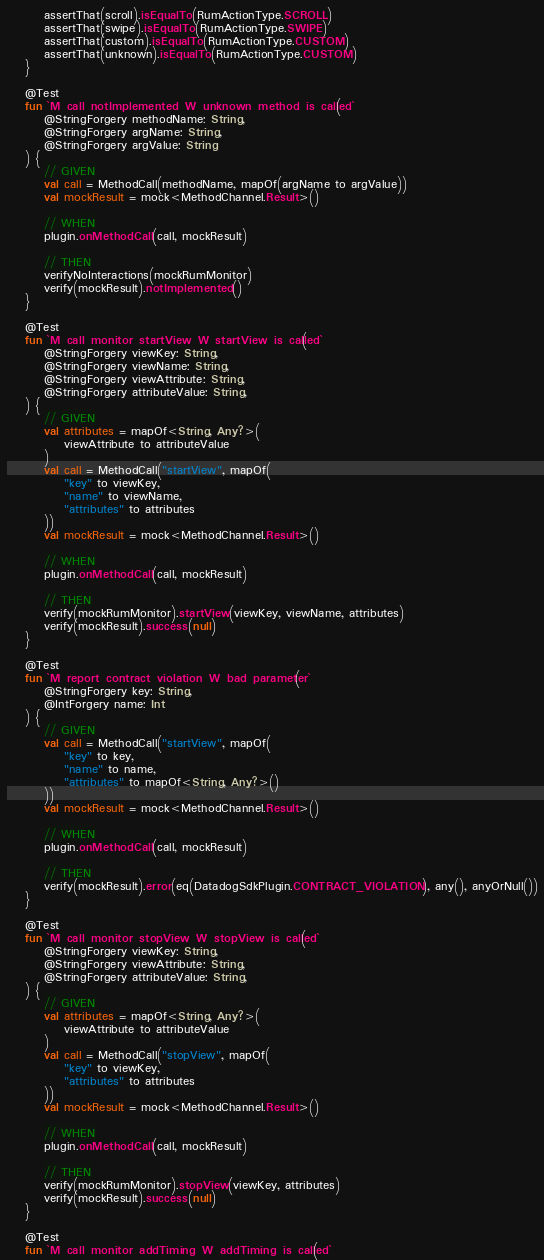<code> <loc_0><loc_0><loc_500><loc_500><_Kotlin_>        assertThat(scroll).isEqualTo(RumActionType.SCROLL)
        assertThat(swipe).isEqualTo(RumActionType.SWIPE)
        assertThat(custom).isEqualTo(RumActionType.CUSTOM)
        assertThat(unknown).isEqualTo(RumActionType.CUSTOM)
    }

    @Test
    fun `M call notImplemented W unknown method is called`(
        @StringForgery methodName: String,
        @StringForgery argName: String,
        @StringForgery argValue: String
    ) {
        // GIVEN
        val call = MethodCall(methodName, mapOf(argName to argValue))
        val mockResult = mock<MethodChannel.Result>()

        // WHEN
        plugin.onMethodCall(call, mockResult)

        // THEN
        verifyNoInteractions(mockRumMonitor)
        verify(mockResult).notImplemented()
    }

    @Test
    fun `M call monitor startView W startView is called`(
        @StringForgery viewKey: String,
        @StringForgery viewName: String,
        @StringForgery viewAttribute: String,
        @StringForgery attributeValue: String,
    ) {
        // GIVEN
        val attributes = mapOf<String, Any?>(
            viewAttribute to attributeValue
        )
        val call = MethodCall("startView", mapOf(
            "key" to viewKey,
            "name" to viewName,
            "attributes" to attributes
        ))
        val mockResult = mock<MethodChannel.Result>()

        // WHEN
        plugin.onMethodCall(call, mockResult)

        // THEN
        verify(mockRumMonitor).startView(viewKey, viewName, attributes)
        verify(mockResult).success(null)
    }

    @Test
    fun `M report contract violation W bad parameter`(
        @StringForgery key: String,
        @IntForgery name: Int
    ) {
        // GIVEN
        val call = MethodCall("startView", mapOf(
            "key" to key,
            "name" to name,
            "attributes" to mapOf<String, Any?>()
        ))
        val mockResult = mock<MethodChannel.Result>()

        // WHEN
        plugin.onMethodCall(call, mockResult)

        // THEN
        verify(mockResult).error(eq(DatadogSdkPlugin.CONTRACT_VIOLATION), any(), anyOrNull())
    }

    @Test
    fun `M call monitor stopView W stopView is called`(
        @StringForgery viewKey: String,
        @StringForgery viewAttribute: String,
        @StringForgery attributeValue: String,
    ) {
        // GIVEN
        val attributes = mapOf<String, Any?>(
            viewAttribute to attributeValue
        )
        val call = MethodCall("stopView", mapOf(
            "key" to viewKey,
            "attributes" to attributes
        ))
        val mockResult = mock<MethodChannel.Result>()

        // WHEN
        plugin.onMethodCall(call, mockResult)

        // THEN
        verify(mockRumMonitor).stopView(viewKey, attributes)
        verify(mockResult).success(null)
    }

    @Test
    fun `M call monitor addTiming W addTiming is called`(</code> 